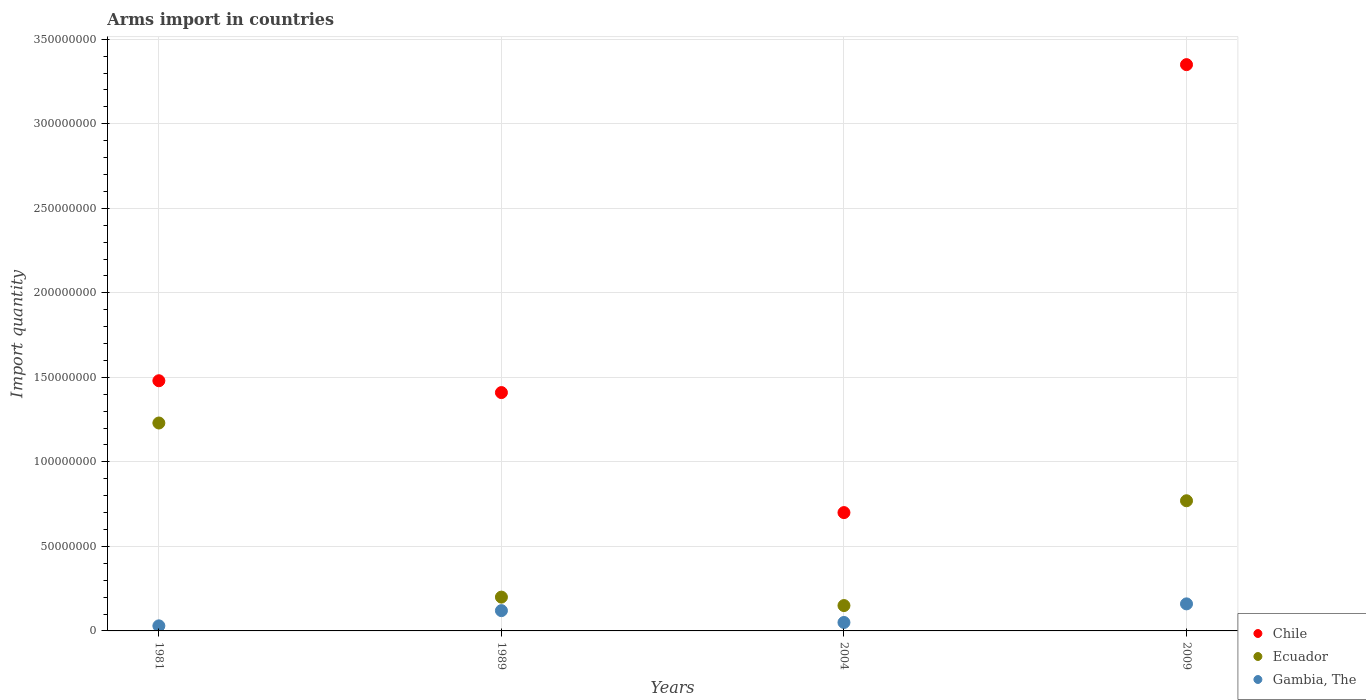How many different coloured dotlines are there?
Give a very brief answer. 3. What is the total arms import in Chile in 2004?
Ensure brevity in your answer.  7.00e+07. Across all years, what is the maximum total arms import in Gambia, The?
Provide a succinct answer. 1.60e+07. Across all years, what is the minimum total arms import in Ecuador?
Ensure brevity in your answer.  1.50e+07. What is the total total arms import in Chile in the graph?
Make the answer very short. 6.94e+08. What is the difference between the total arms import in Gambia, The in 1981 and that in 1989?
Provide a succinct answer. -9.00e+06. What is the difference between the total arms import in Chile in 2004 and the total arms import in Ecuador in 1981?
Give a very brief answer. -5.30e+07. What is the average total arms import in Chile per year?
Ensure brevity in your answer.  1.74e+08. In the year 1981, what is the difference between the total arms import in Ecuador and total arms import in Gambia, The?
Offer a terse response. 1.20e+08. Is the difference between the total arms import in Ecuador in 2004 and 2009 greater than the difference between the total arms import in Gambia, The in 2004 and 2009?
Offer a terse response. No. What is the difference between the highest and the second highest total arms import in Chile?
Your response must be concise. 1.87e+08. What is the difference between the highest and the lowest total arms import in Gambia, The?
Offer a terse response. 1.30e+07. In how many years, is the total arms import in Chile greater than the average total arms import in Chile taken over all years?
Offer a very short reply. 1. Does the total arms import in Gambia, The monotonically increase over the years?
Your answer should be compact. No. Is the total arms import in Chile strictly less than the total arms import in Ecuador over the years?
Your answer should be very brief. No. How many dotlines are there?
Your answer should be very brief. 3. How many years are there in the graph?
Offer a very short reply. 4. What is the difference between two consecutive major ticks on the Y-axis?
Your answer should be very brief. 5.00e+07. Does the graph contain any zero values?
Ensure brevity in your answer.  No. Does the graph contain grids?
Offer a very short reply. Yes. Where does the legend appear in the graph?
Ensure brevity in your answer.  Bottom right. How many legend labels are there?
Your answer should be very brief. 3. How are the legend labels stacked?
Provide a succinct answer. Vertical. What is the title of the graph?
Ensure brevity in your answer.  Arms import in countries. Does "Finland" appear as one of the legend labels in the graph?
Offer a very short reply. No. What is the label or title of the Y-axis?
Your answer should be very brief. Import quantity. What is the Import quantity of Chile in 1981?
Keep it short and to the point. 1.48e+08. What is the Import quantity of Ecuador in 1981?
Keep it short and to the point. 1.23e+08. What is the Import quantity of Gambia, The in 1981?
Your answer should be compact. 3.00e+06. What is the Import quantity of Chile in 1989?
Your answer should be very brief. 1.41e+08. What is the Import quantity of Chile in 2004?
Give a very brief answer. 7.00e+07. What is the Import quantity in Ecuador in 2004?
Give a very brief answer. 1.50e+07. What is the Import quantity of Gambia, The in 2004?
Your answer should be compact. 5.00e+06. What is the Import quantity of Chile in 2009?
Ensure brevity in your answer.  3.35e+08. What is the Import quantity of Ecuador in 2009?
Offer a very short reply. 7.70e+07. What is the Import quantity in Gambia, The in 2009?
Give a very brief answer. 1.60e+07. Across all years, what is the maximum Import quantity of Chile?
Ensure brevity in your answer.  3.35e+08. Across all years, what is the maximum Import quantity in Ecuador?
Keep it short and to the point. 1.23e+08. Across all years, what is the maximum Import quantity of Gambia, The?
Your answer should be very brief. 1.60e+07. Across all years, what is the minimum Import quantity of Chile?
Offer a terse response. 7.00e+07. Across all years, what is the minimum Import quantity in Ecuador?
Provide a short and direct response. 1.50e+07. Across all years, what is the minimum Import quantity in Gambia, The?
Your answer should be very brief. 3.00e+06. What is the total Import quantity in Chile in the graph?
Your response must be concise. 6.94e+08. What is the total Import quantity of Ecuador in the graph?
Provide a succinct answer. 2.35e+08. What is the total Import quantity of Gambia, The in the graph?
Offer a very short reply. 3.60e+07. What is the difference between the Import quantity in Ecuador in 1981 and that in 1989?
Make the answer very short. 1.03e+08. What is the difference between the Import quantity of Gambia, The in 1981 and that in 1989?
Ensure brevity in your answer.  -9.00e+06. What is the difference between the Import quantity of Chile in 1981 and that in 2004?
Offer a terse response. 7.80e+07. What is the difference between the Import quantity of Ecuador in 1981 and that in 2004?
Offer a very short reply. 1.08e+08. What is the difference between the Import quantity of Chile in 1981 and that in 2009?
Provide a succinct answer. -1.87e+08. What is the difference between the Import quantity of Ecuador in 1981 and that in 2009?
Provide a short and direct response. 4.60e+07. What is the difference between the Import quantity of Gambia, The in 1981 and that in 2009?
Your answer should be compact. -1.30e+07. What is the difference between the Import quantity in Chile in 1989 and that in 2004?
Offer a very short reply. 7.10e+07. What is the difference between the Import quantity in Chile in 1989 and that in 2009?
Your answer should be very brief. -1.94e+08. What is the difference between the Import quantity in Ecuador in 1989 and that in 2009?
Make the answer very short. -5.70e+07. What is the difference between the Import quantity in Gambia, The in 1989 and that in 2009?
Provide a short and direct response. -4.00e+06. What is the difference between the Import quantity in Chile in 2004 and that in 2009?
Keep it short and to the point. -2.65e+08. What is the difference between the Import quantity in Ecuador in 2004 and that in 2009?
Your answer should be very brief. -6.20e+07. What is the difference between the Import quantity of Gambia, The in 2004 and that in 2009?
Provide a short and direct response. -1.10e+07. What is the difference between the Import quantity of Chile in 1981 and the Import quantity of Ecuador in 1989?
Provide a succinct answer. 1.28e+08. What is the difference between the Import quantity of Chile in 1981 and the Import quantity of Gambia, The in 1989?
Offer a terse response. 1.36e+08. What is the difference between the Import quantity in Ecuador in 1981 and the Import quantity in Gambia, The in 1989?
Offer a terse response. 1.11e+08. What is the difference between the Import quantity of Chile in 1981 and the Import quantity of Ecuador in 2004?
Keep it short and to the point. 1.33e+08. What is the difference between the Import quantity of Chile in 1981 and the Import quantity of Gambia, The in 2004?
Give a very brief answer. 1.43e+08. What is the difference between the Import quantity of Ecuador in 1981 and the Import quantity of Gambia, The in 2004?
Offer a terse response. 1.18e+08. What is the difference between the Import quantity in Chile in 1981 and the Import quantity in Ecuador in 2009?
Keep it short and to the point. 7.10e+07. What is the difference between the Import quantity in Chile in 1981 and the Import quantity in Gambia, The in 2009?
Provide a short and direct response. 1.32e+08. What is the difference between the Import quantity of Ecuador in 1981 and the Import quantity of Gambia, The in 2009?
Offer a terse response. 1.07e+08. What is the difference between the Import quantity of Chile in 1989 and the Import quantity of Ecuador in 2004?
Give a very brief answer. 1.26e+08. What is the difference between the Import quantity in Chile in 1989 and the Import quantity in Gambia, The in 2004?
Your answer should be compact. 1.36e+08. What is the difference between the Import quantity in Ecuador in 1989 and the Import quantity in Gambia, The in 2004?
Provide a succinct answer. 1.50e+07. What is the difference between the Import quantity of Chile in 1989 and the Import quantity of Ecuador in 2009?
Offer a very short reply. 6.40e+07. What is the difference between the Import quantity in Chile in 1989 and the Import quantity in Gambia, The in 2009?
Your response must be concise. 1.25e+08. What is the difference between the Import quantity in Ecuador in 1989 and the Import quantity in Gambia, The in 2009?
Make the answer very short. 4.00e+06. What is the difference between the Import quantity of Chile in 2004 and the Import quantity of Ecuador in 2009?
Your response must be concise. -7.00e+06. What is the difference between the Import quantity of Chile in 2004 and the Import quantity of Gambia, The in 2009?
Your answer should be very brief. 5.40e+07. What is the difference between the Import quantity of Ecuador in 2004 and the Import quantity of Gambia, The in 2009?
Ensure brevity in your answer.  -1.00e+06. What is the average Import quantity of Chile per year?
Make the answer very short. 1.74e+08. What is the average Import quantity of Ecuador per year?
Ensure brevity in your answer.  5.88e+07. What is the average Import quantity of Gambia, The per year?
Provide a short and direct response. 9.00e+06. In the year 1981, what is the difference between the Import quantity in Chile and Import quantity in Ecuador?
Ensure brevity in your answer.  2.50e+07. In the year 1981, what is the difference between the Import quantity of Chile and Import quantity of Gambia, The?
Offer a very short reply. 1.45e+08. In the year 1981, what is the difference between the Import quantity in Ecuador and Import quantity in Gambia, The?
Keep it short and to the point. 1.20e+08. In the year 1989, what is the difference between the Import quantity in Chile and Import quantity in Ecuador?
Give a very brief answer. 1.21e+08. In the year 1989, what is the difference between the Import quantity of Chile and Import quantity of Gambia, The?
Ensure brevity in your answer.  1.29e+08. In the year 2004, what is the difference between the Import quantity in Chile and Import quantity in Ecuador?
Your answer should be very brief. 5.50e+07. In the year 2004, what is the difference between the Import quantity in Chile and Import quantity in Gambia, The?
Offer a terse response. 6.50e+07. In the year 2004, what is the difference between the Import quantity of Ecuador and Import quantity of Gambia, The?
Provide a short and direct response. 1.00e+07. In the year 2009, what is the difference between the Import quantity of Chile and Import quantity of Ecuador?
Offer a terse response. 2.58e+08. In the year 2009, what is the difference between the Import quantity in Chile and Import quantity in Gambia, The?
Make the answer very short. 3.19e+08. In the year 2009, what is the difference between the Import quantity of Ecuador and Import quantity of Gambia, The?
Offer a very short reply. 6.10e+07. What is the ratio of the Import quantity in Chile in 1981 to that in 1989?
Offer a terse response. 1.05. What is the ratio of the Import quantity in Ecuador in 1981 to that in 1989?
Provide a short and direct response. 6.15. What is the ratio of the Import quantity in Gambia, The in 1981 to that in 1989?
Ensure brevity in your answer.  0.25. What is the ratio of the Import quantity in Chile in 1981 to that in 2004?
Offer a terse response. 2.11. What is the ratio of the Import quantity of Ecuador in 1981 to that in 2004?
Your answer should be very brief. 8.2. What is the ratio of the Import quantity in Chile in 1981 to that in 2009?
Provide a short and direct response. 0.44. What is the ratio of the Import quantity in Ecuador in 1981 to that in 2009?
Provide a succinct answer. 1.6. What is the ratio of the Import quantity of Gambia, The in 1981 to that in 2009?
Your response must be concise. 0.19. What is the ratio of the Import quantity in Chile in 1989 to that in 2004?
Provide a short and direct response. 2.01. What is the ratio of the Import quantity of Ecuador in 1989 to that in 2004?
Provide a short and direct response. 1.33. What is the ratio of the Import quantity of Gambia, The in 1989 to that in 2004?
Offer a terse response. 2.4. What is the ratio of the Import quantity in Chile in 1989 to that in 2009?
Your answer should be compact. 0.42. What is the ratio of the Import quantity in Ecuador in 1989 to that in 2009?
Offer a very short reply. 0.26. What is the ratio of the Import quantity in Chile in 2004 to that in 2009?
Offer a terse response. 0.21. What is the ratio of the Import quantity in Ecuador in 2004 to that in 2009?
Give a very brief answer. 0.19. What is the ratio of the Import quantity in Gambia, The in 2004 to that in 2009?
Provide a short and direct response. 0.31. What is the difference between the highest and the second highest Import quantity in Chile?
Ensure brevity in your answer.  1.87e+08. What is the difference between the highest and the second highest Import quantity in Ecuador?
Your response must be concise. 4.60e+07. What is the difference between the highest and the second highest Import quantity of Gambia, The?
Ensure brevity in your answer.  4.00e+06. What is the difference between the highest and the lowest Import quantity in Chile?
Offer a terse response. 2.65e+08. What is the difference between the highest and the lowest Import quantity in Ecuador?
Your answer should be compact. 1.08e+08. What is the difference between the highest and the lowest Import quantity in Gambia, The?
Your response must be concise. 1.30e+07. 